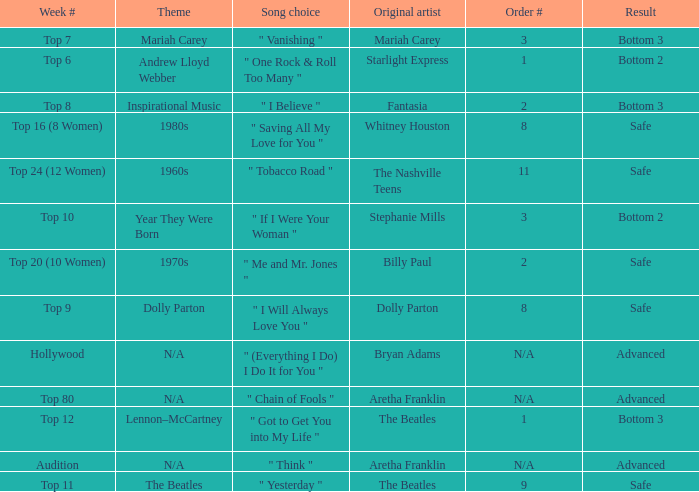Name the order number for the beatles and result is safe 9.0. 